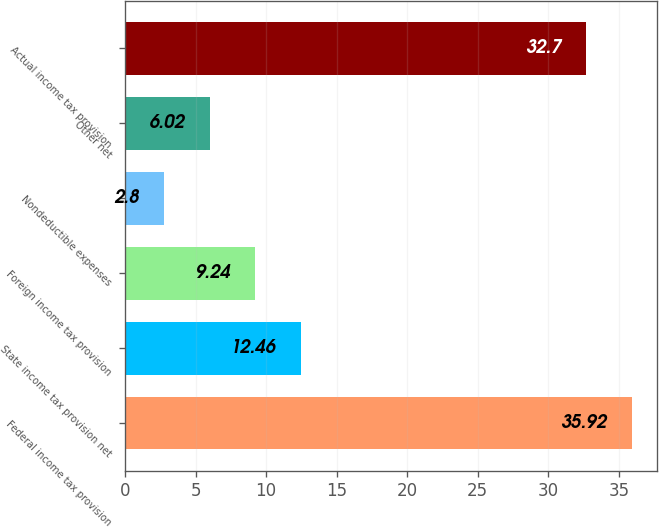Convert chart. <chart><loc_0><loc_0><loc_500><loc_500><bar_chart><fcel>Federal income tax provision<fcel>State income tax provision net<fcel>Foreign income tax provision<fcel>Nondeductible expenses<fcel>Other net<fcel>Actual income tax provision<nl><fcel>35.92<fcel>12.46<fcel>9.24<fcel>2.8<fcel>6.02<fcel>32.7<nl></chart> 